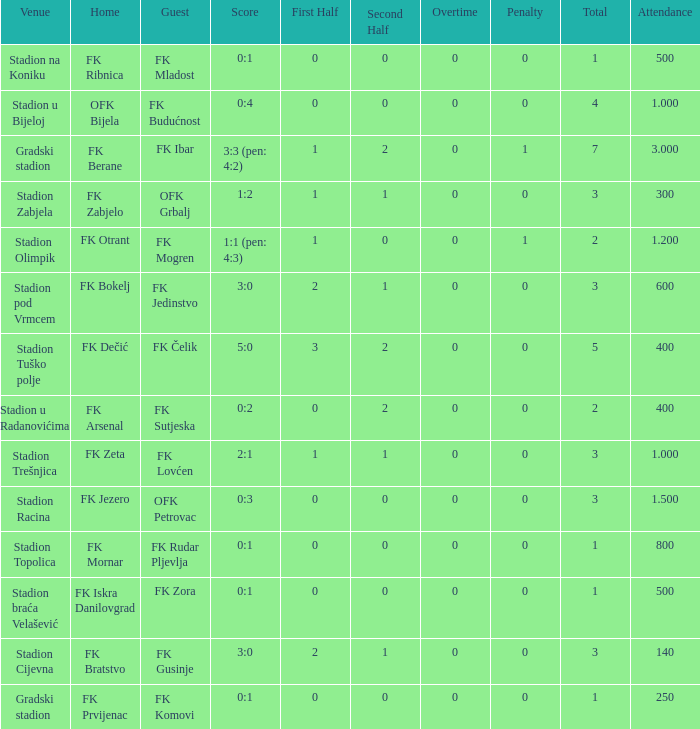What was the presence count for the match featuring an away team of fk mogren? 1.2. 